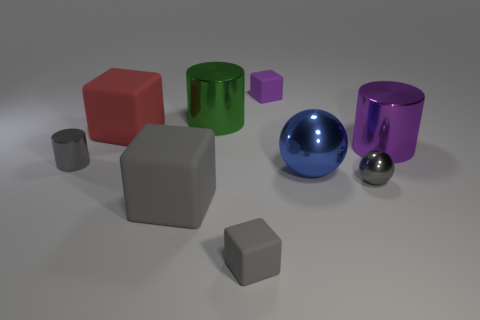There is a purple shiny object; does it have the same shape as the tiny gray metallic object that is left of the green thing?
Your answer should be very brief. Yes. What number of red matte objects have the same size as the blue metallic sphere?
Give a very brief answer. 1. There is a large red object that is the same shape as the small gray rubber object; what material is it?
Your answer should be compact. Rubber. There is a large thing that is in front of the big ball; is its color the same as the object that is behind the green thing?
Provide a succinct answer. No. What is the shape of the big metal thing that is to the left of the small purple matte object?
Your response must be concise. Cylinder. What color is the tiny metallic cylinder?
Make the answer very short. Gray. There is a blue thing that is the same material as the gray ball; what is its shape?
Give a very brief answer. Sphere. There is a purple object that is on the left side of the blue object; does it have the same size as the big blue metallic sphere?
Give a very brief answer. No. How many objects are big metallic cylinders that are on the right side of the purple rubber block or big matte cubes in front of the small gray metal cylinder?
Offer a very short reply. 2. There is a big cube in front of the gray metal cylinder; is it the same color as the large metallic ball?
Make the answer very short. No. 